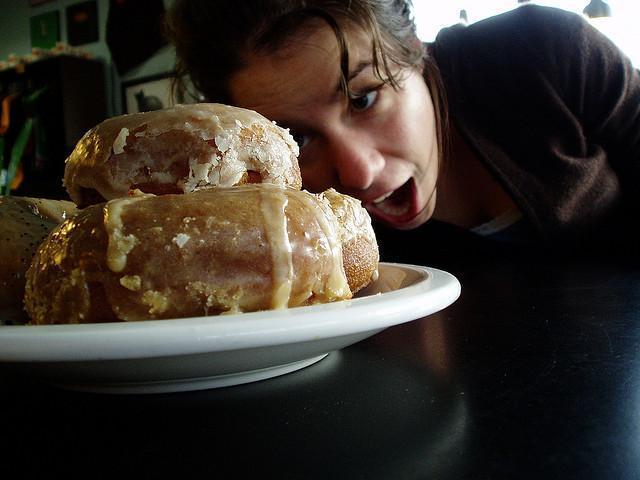How many dining tables can be seen?
Give a very brief answer. 2. How many donuts are there?
Give a very brief answer. 3. 